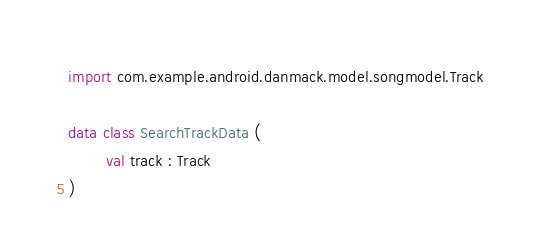<code> <loc_0><loc_0><loc_500><loc_500><_Kotlin_>import com.example.android.danmack.model.songmodel.Track

data class SearchTrackData (
        val track : Track
)</code> 